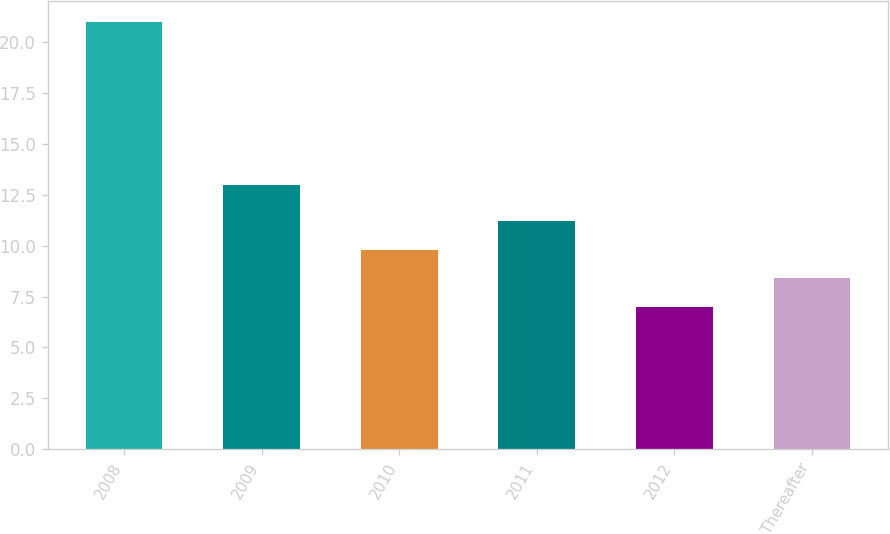Convert chart. <chart><loc_0><loc_0><loc_500><loc_500><bar_chart><fcel>2008<fcel>2009<fcel>2010<fcel>2011<fcel>2012<fcel>Thereafter<nl><fcel>21<fcel>13<fcel>9.8<fcel>11.2<fcel>7<fcel>8.4<nl></chart> 